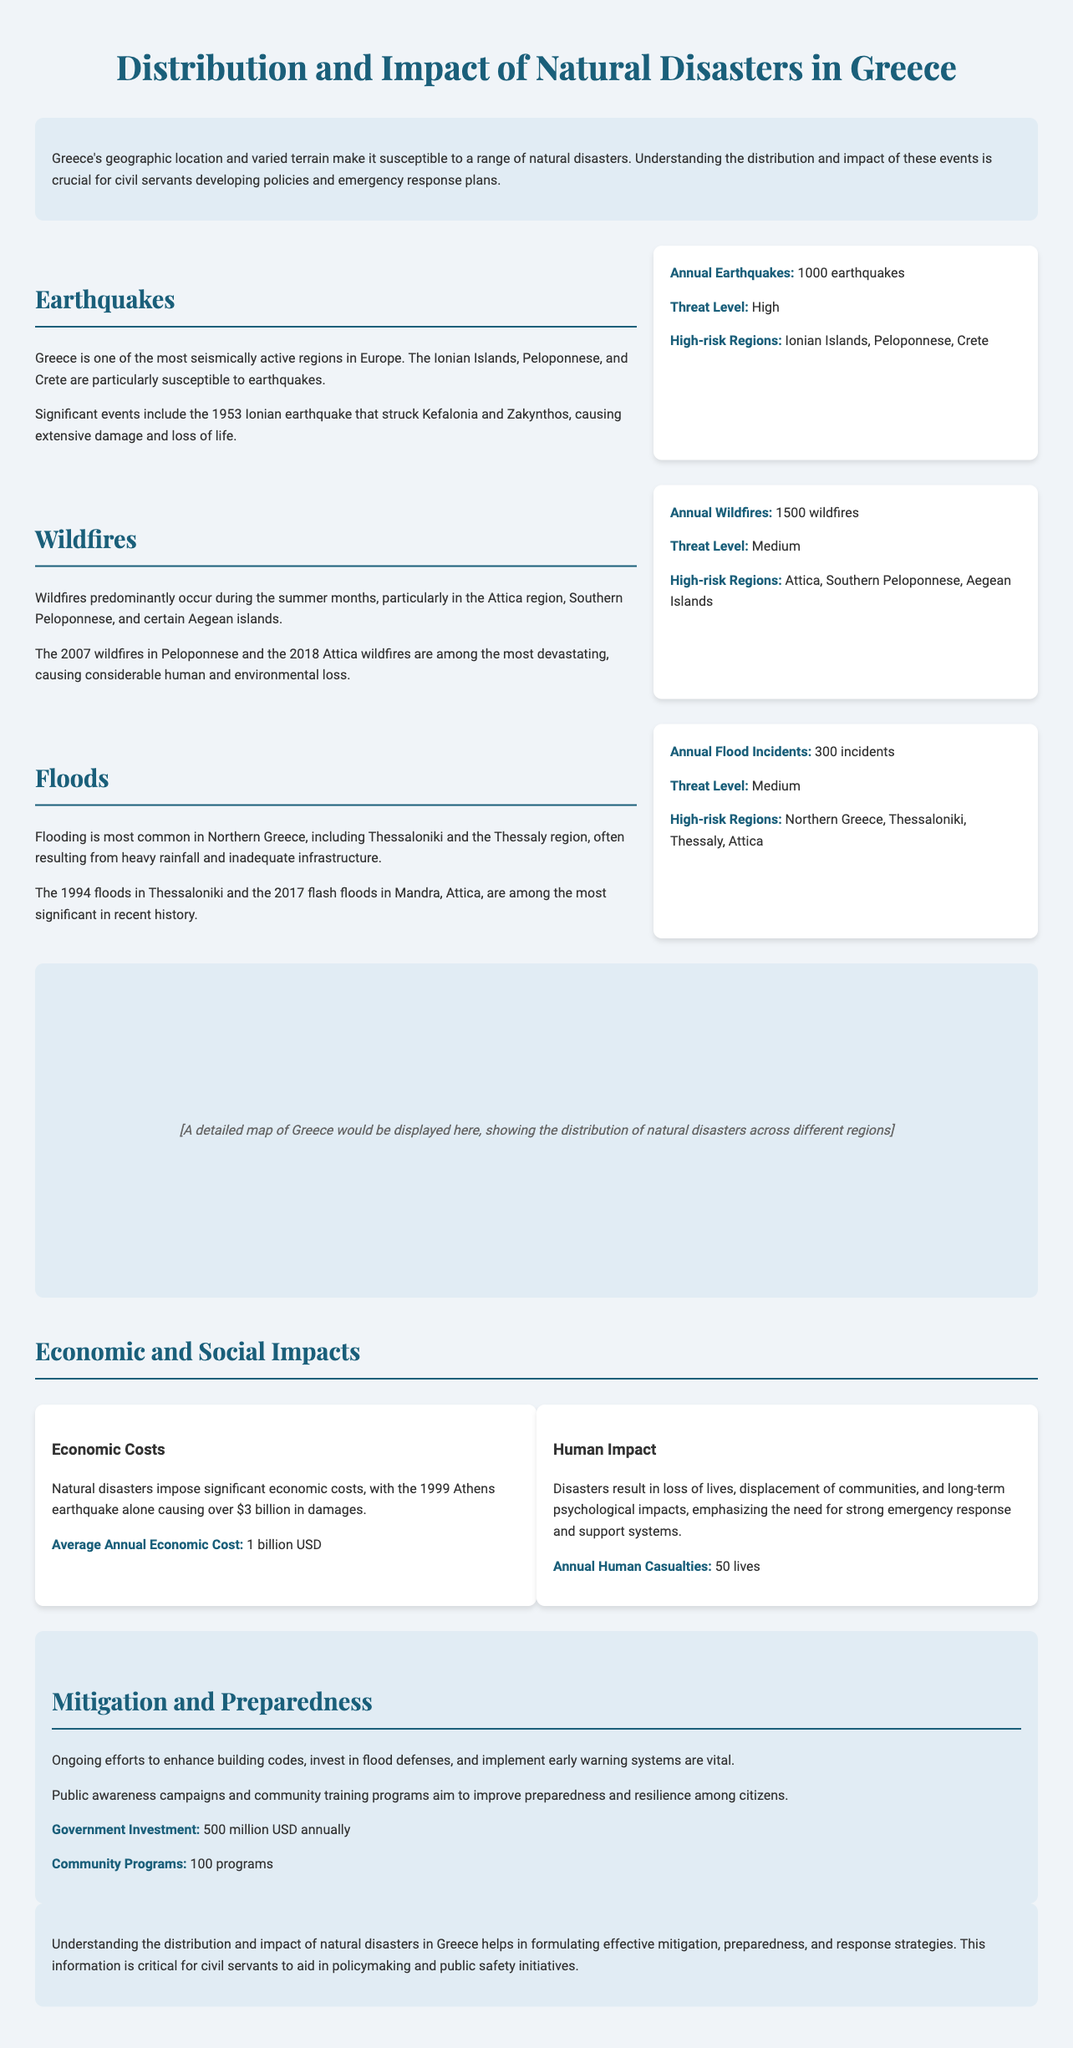what is the average annual economic cost of natural disasters in Greece? The document states that the average annual economic cost of natural disasters is 1 billion USD.
Answer: 1 billion USD what is the threat level for earthquakes in Greece? The threat level for earthquakes is classified as high according to the document.
Answer: High which region is most susceptible to wildfires? The document indicates that the Attica region is particularly susceptible to wildfires.
Answer: Attica how many programs are initiated for community preparedness? The document mentions that there are 100 community programs aimed at improving preparedness.
Answer: 100 programs what is the total annual number of earthquakes in Greece? The annual number of earthquakes is specified as 1000 earthquakes in the document.
Answer: 1000 earthquakes what natural disaster caused over $3 billion in damages? The 1999 Athens earthquake caused over $3 billion in damages according to the document.
Answer: 1999 Athens earthquake which regions of Greece are high-risk for floods? According to the document, the high-risk regions for floods include Northern Greece, Thessaloniki, Thessaly, and Attica.
Answer: Northern Greece, Thessaloniki, Thessaly, Attica what is the annual number of wildfires reported in Greece? The document specifies that there are 1500 wildfires annually in Greece.
Answer: 1500 wildfires what investment amount is allocated annually by the government for disaster mitigation? The document states that the government invests 500 million USD annually in disaster mitigation.
Answer: 500 million USD 